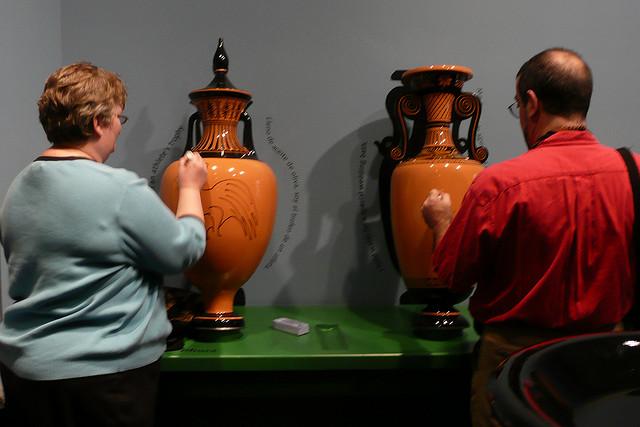What is in the vase?
Write a very short answer. Nothing. How many tables are in this room?
Concise answer only. 1. What language is the writing on the pot?
Answer briefly. English. What type of animal is painted on the side of the vase on the left?
Concise answer only. Bird. Are there plates in the background?
Write a very short answer. No. Are one of these people balding?
Answer briefly. Yes. What are the main colors in the picture?
Keep it brief. Orange. How many vases are displayed?
Concise answer only. 2. How many of the vases have lids?
Quick response, please. 1. How many people have glasses?
Give a very brief answer. 2. What color is the wall?
Give a very brief answer. Gray. What color is the mantle?
Short answer required. Green. Is there water in the vase?
Quick response, please. No. How many people are in this picture?
Keep it brief. 2. What is the woman doing to the vase?
Keep it brief. Painting. What color is the table?
Concise answer only. Green. What is the table made of?
Quick response, please. Wood. Is something growing in the vase?
Write a very short answer. No. What animal appears on both vases?
Short answer required. Rooster. What is on the wall behind the vase?
Quick response, please. Writing. Are the vases the same?
Short answer required. No. 